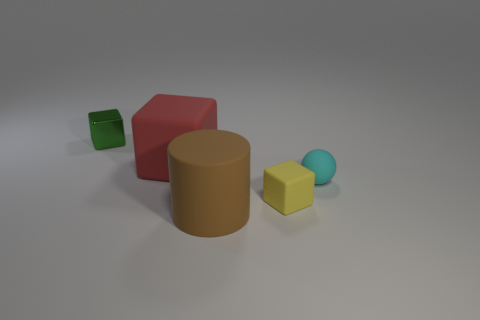Add 3 big yellow matte objects. How many objects exist? 8 Subtract all red blocks. How many blocks are left? 2 Subtract all big blocks. How many blocks are left? 2 Subtract all cylinders. How many objects are left? 4 Subtract all purple cubes. Subtract all red cylinders. How many cubes are left? 3 Subtract all purple cylinders. How many brown blocks are left? 0 Subtract all brown matte cylinders. Subtract all small cyan objects. How many objects are left? 3 Add 5 tiny yellow cubes. How many tiny yellow cubes are left? 6 Add 4 tiny things. How many tiny things exist? 7 Subtract 1 cyan spheres. How many objects are left? 4 